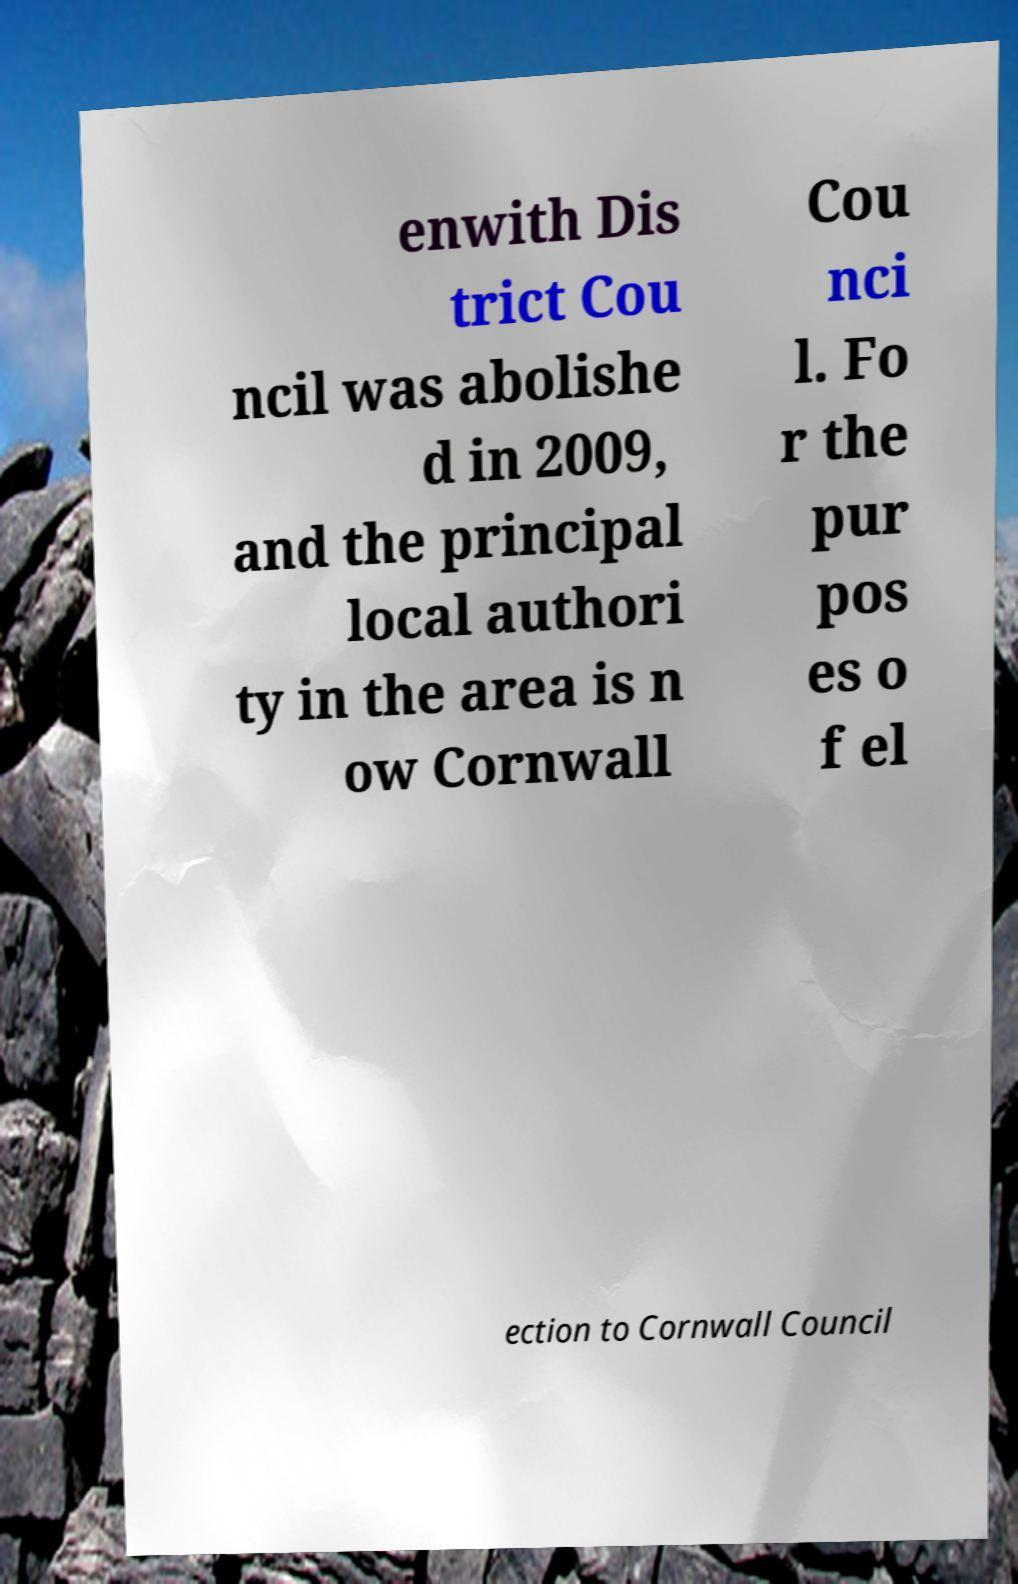There's text embedded in this image that I need extracted. Can you transcribe it verbatim? enwith Dis trict Cou ncil was abolishe d in 2009, and the principal local authori ty in the area is n ow Cornwall Cou nci l. Fo r the pur pos es o f el ection to Cornwall Council 